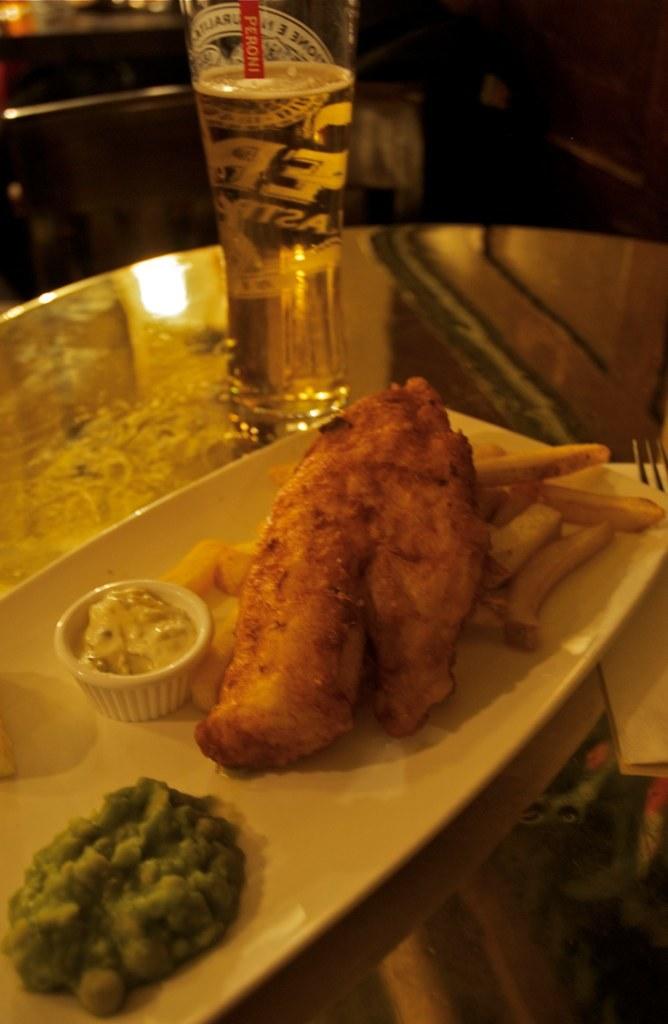I wonder what kind of beer that is?
Keep it short and to the point. Unanswerable. Is the food picture?
Provide a short and direct response. Answering does not require reading text in the image. 